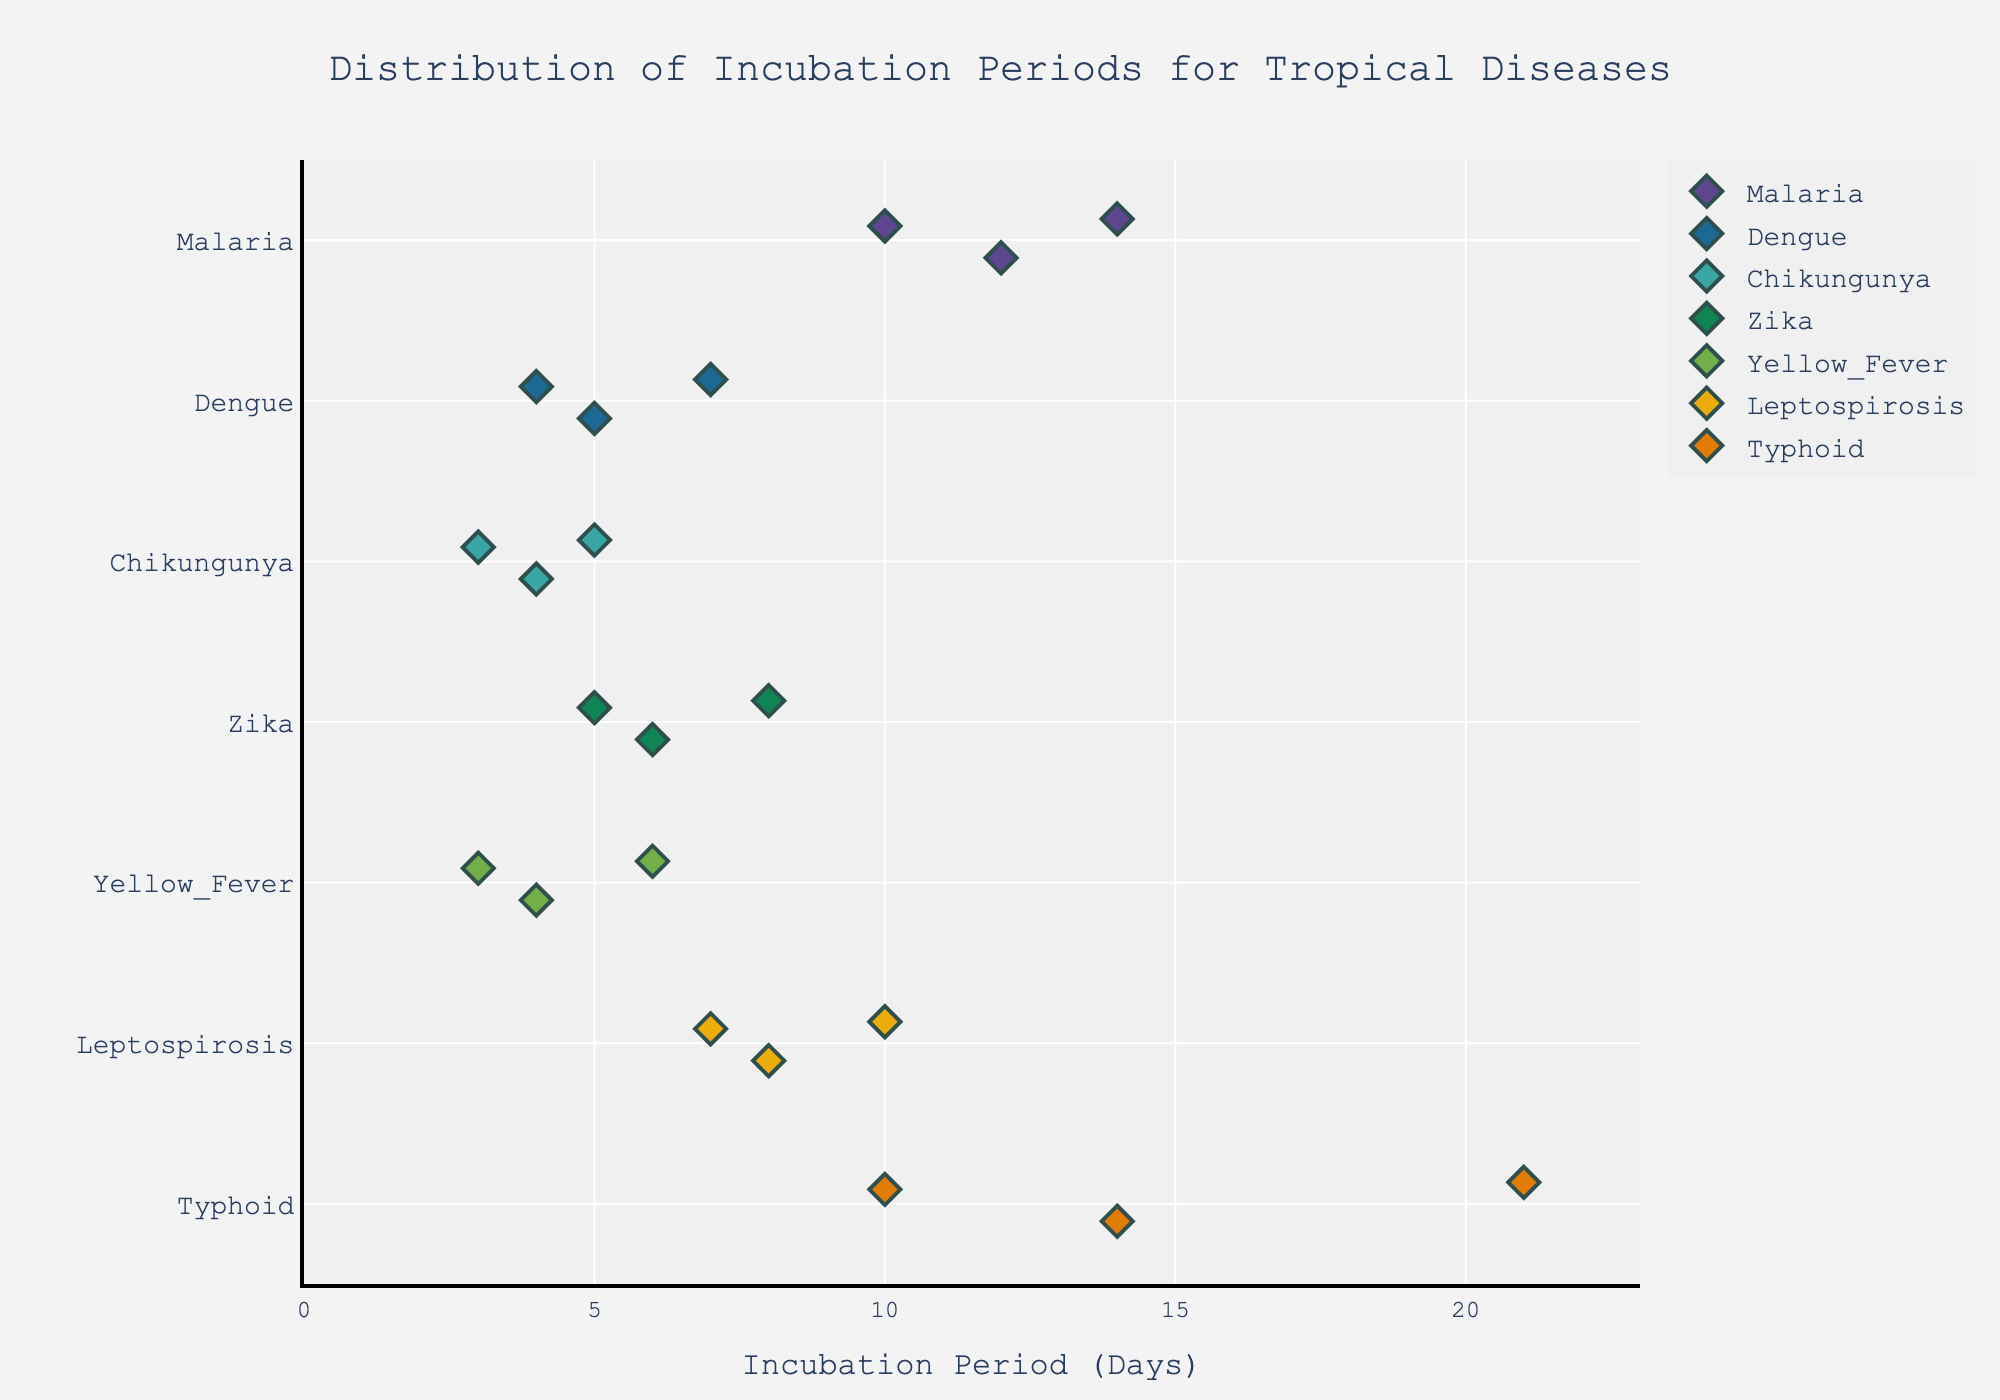Which disease has the shortest incubation period displayed on the plot? The shortest incubation period is the lowest value on the x-axis, which corresponds to Chikungunya with an incubation period of 3 days.
Answer: Chikungunya How many incubation periods are displayed for Typhoid? Count the number of data points (diamonds) plotted for Typhoid along the y-axis. There are 3 such points.
Answer: 3 Which disease has the highest range of incubation periods? Find the disease with the largest interval on the x-axis. Typhoid ranges from 10 to 21 days, which is the largest range (11 days).
Answer: Typhoid What is the median incubation period for Zika? Zika has three points: 5, 6, and 8 days. The middle value is 6 days.
Answer: 6 Compare the average incubation period of Malaria and Dengue. Which one is higher? Calculate the average for each disease: Malaria (12+14+10)/3 = 12, Dengue (5+7+4)/3 = 5.33. Malaria has a higher average.
Answer: Malaria Which diseases have incubation periods overlapping with Dengue? Dengue ranges from 4 to 7 days. Overlapping ranges are Chikungunya (3-5), Zika (5-8), and Yellow Fever (3-6).
Answer: Chikungunya, Zika, Yellow Fever What is the title of the plot? The title is located at the top of the plot. It reads "Distribution of Incubation Periods for Tropical Diseases".
Answer: Distribution of Incubation Periods for Tropical Diseases Does Yellow Fever have any incubation periods longer than Zika? Compare their maximum values: Yellow Fever's highest value is 6, while Zika's highest value is 8. Yellow Fever does not have higher values than Zika.
Answer: No 